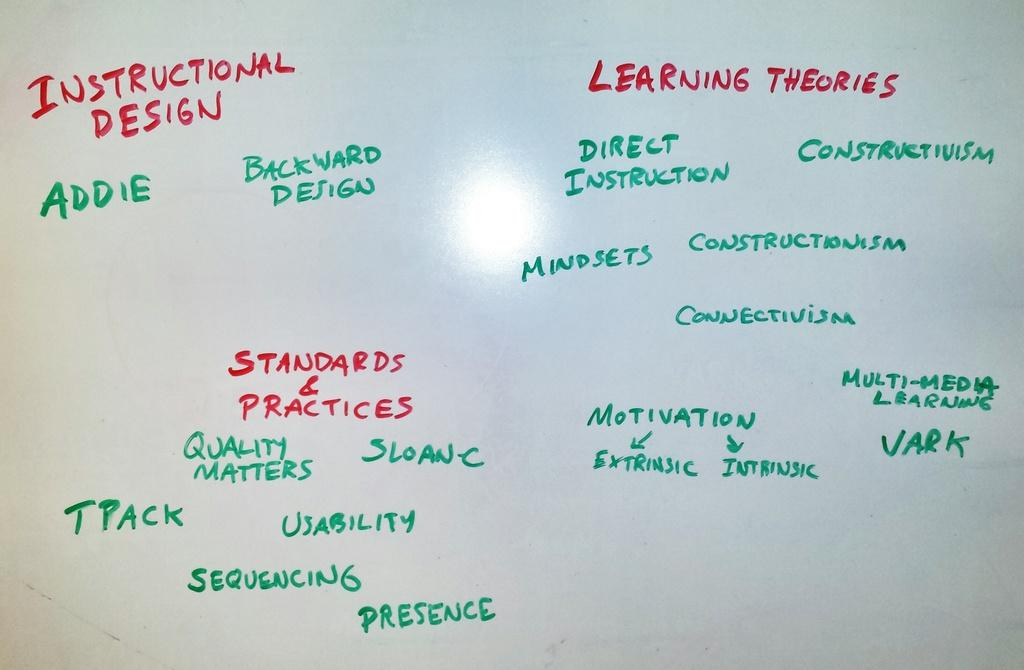<image>
Describe the image concisely. A white board has instructional design written on it in red. 